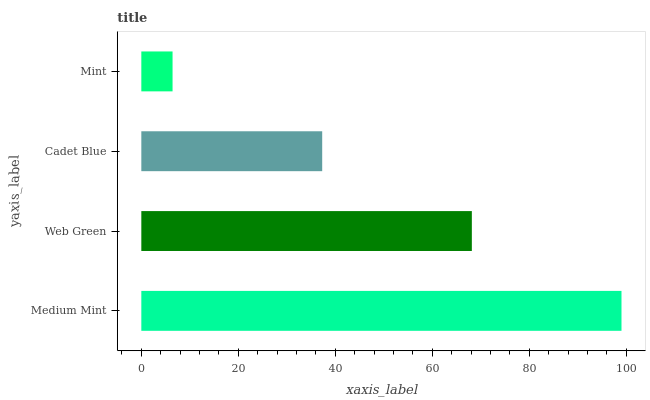Is Mint the minimum?
Answer yes or no. Yes. Is Medium Mint the maximum?
Answer yes or no. Yes. Is Web Green the minimum?
Answer yes or no. No. Is Web Green the maximum?
Answer yes or no. No. Is Medium Mint greater than Web Green?
Answer yes or no. Yes. Is Web Green less than Medium Mint?
Answer yes or no. Yes. Is Web Green greater than Medium Mint?
Answer yes or no. No. Is Medium Mint less than Web Green?
Answer yes or no. No. Is Web Green the high median?
Answer yes or no. Yes. Is Cadet Blue the low median?
Answer yes or no. Yes. Is Medium Mint the high median?
Answer yes or no. No. Is Medium Mint the low median?
Answer yes or no. No. 